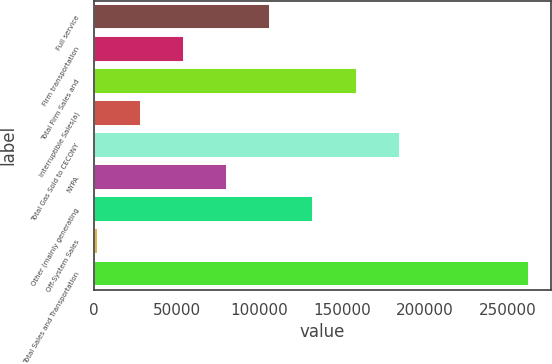Convert chart. <chart><loc_0><loc_0><loc_500><loc_500><bar_chart><fcel>Full service<fcel>Firm transportation<fcel>Total Firm Sales and<fcel>Interruptible Sales(a)<fcel>Total Gas Sold to CECONY<fcel>NYPA<fcel>Other (mainly generating<fcel>Off-System Sales<fcel>Total Sales and Transportation<nl><fcel>106594<fcel>54459.6<fcel>158729<fcel>28392.3<fcel>184796<fcel>80526.9<fcel>132662<fcel>2325<fcel>262998<nl></chart> 